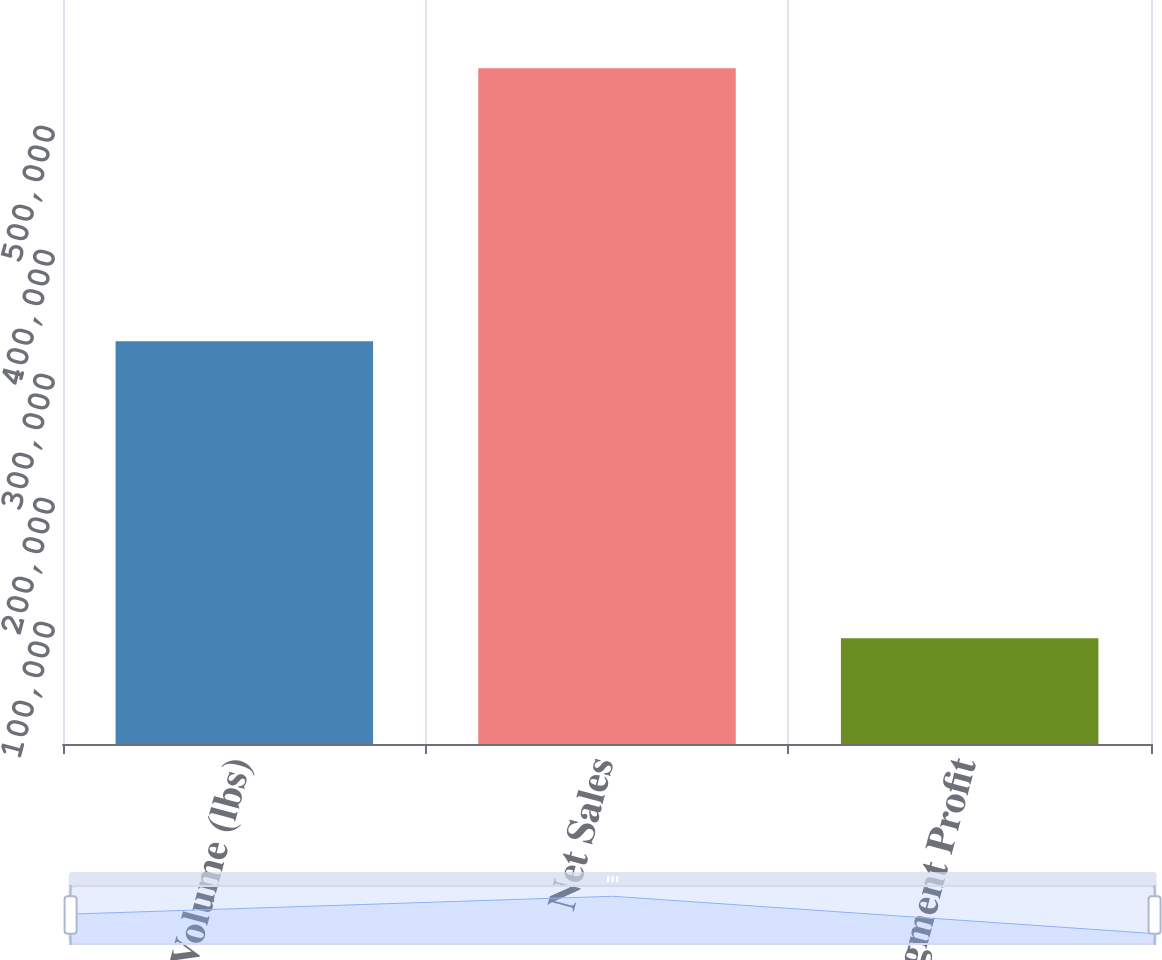Convert chart to OTSL. <chart><loc_0><loc_0><loc_500><loc_500><bar_chart><fcel>Volume (lbs)<fcel>Net Sales<fcel>Segment Profit<nl><fcel>324895<fcel>545014<fcel>85304<nl></chart> 